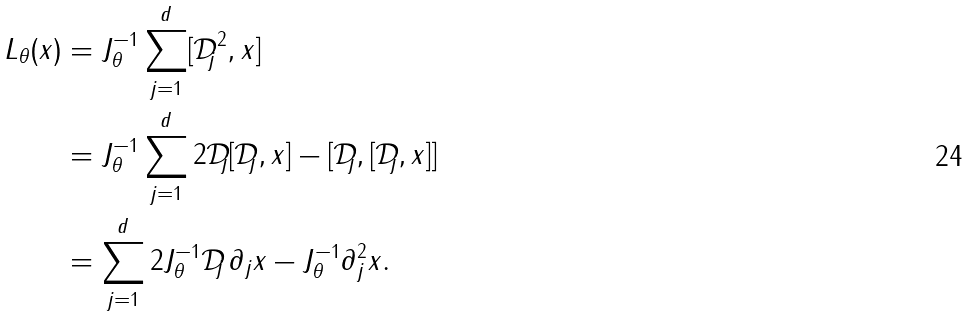<formula> <loc_0><loc_0><loc_500><loc_500>L _ { \theta } ( x ) & = J _ { \theta } ^ { - 1 } \sum _ { j = 1 } ^ { d } [ { \mathcal { D } } _ { j } ^ { 2 } , x ] \\ & = J _ { \theta } ^ { - 1 } \sum _ { j = 1 } ^ { d } 2 { \mathcal { D } } _ { j } [ { \mathcal { D } } _ { j } , x ] - [ { \mathcal { D } } _ { j } , [ { \mathcal { D } } _ { j } , x ] ] \\ & = \sum _ { j = 1 } ^ { d } 2 J _ { \theta } ^ { - 1 } { \mathcal { D } } _ { j } \, \partial _ { j } x - J _ { \theta } ^ { - 1 } \partial ^ { 2 } _ { j } x .</formula> 